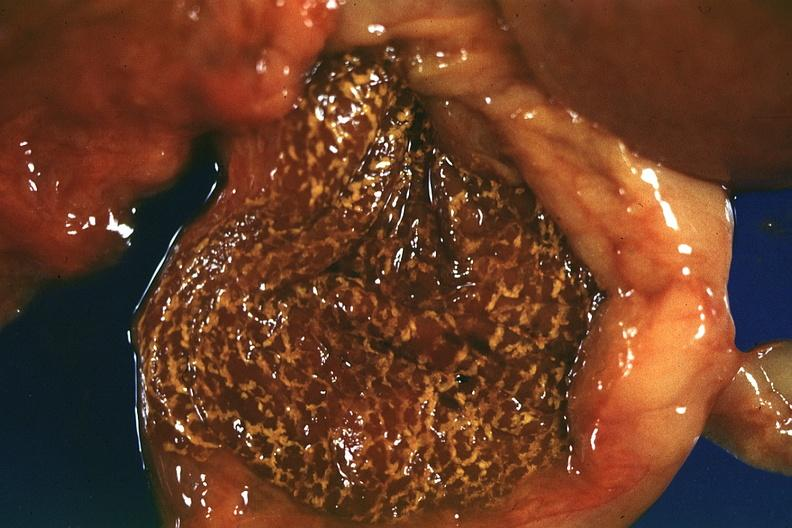s hepatobiliary present?
Answer the question using a single word or phrase. Yes 